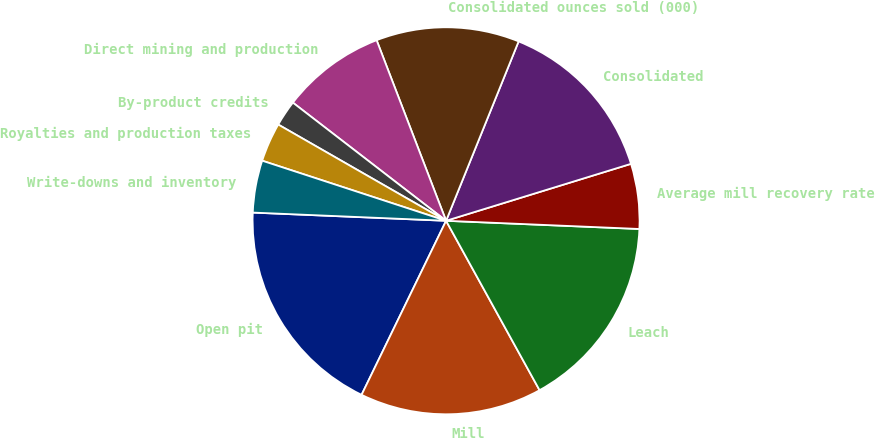Convert chart. <chart><loc_0><loc_0><loc_500><loc_500><pie_chart><fcel>Open pit<fcel>Mill<fcel>Leach<fcel>Average mill recovery rate<fcel>Consolidated<fcel>Consolidated ounces sold (000)<fcel>Direct mining and production<fcel>By-product credits<fcel>Royalties and production taxes<fcel>Write-downs and inventory<nl><fcel>18.48%<fcel>15.22%<fcel>16.3%<fcel>5.43%<fcel>14.13%<fcel>11.96%<fcel>8.7%<fcel>2.17%<fcel>3.26%<fcel>4.35%<nl></chart> 